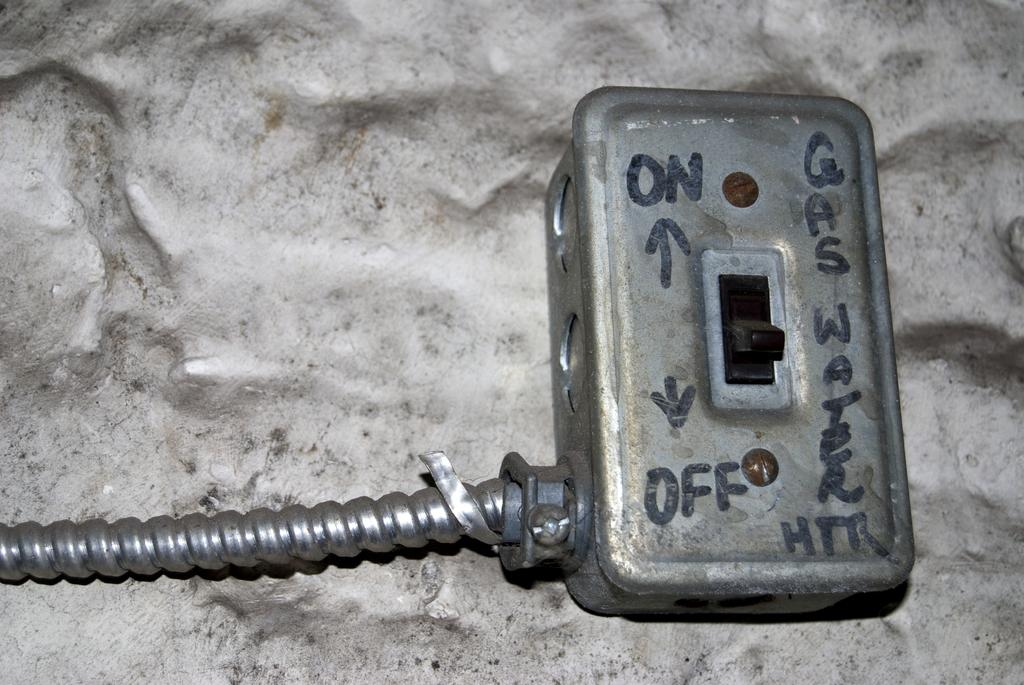Provide a one-sentence caption for the provided image. A grey on off switch that powers a gas water heater. 